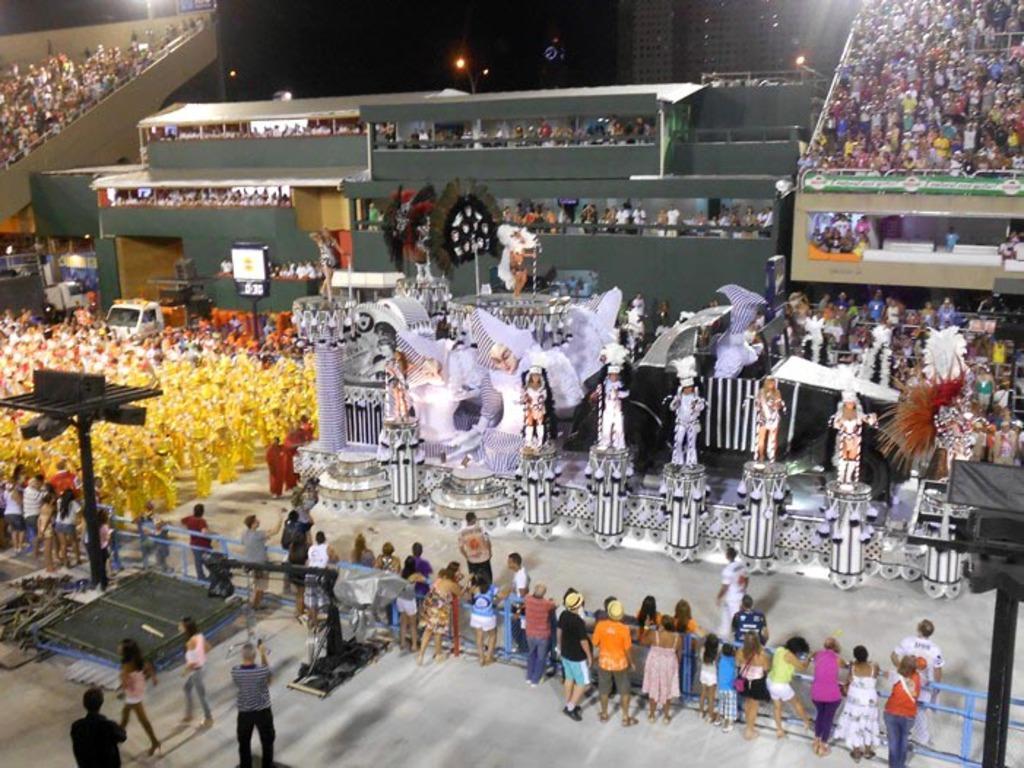Could you give a brief overview of what you see in this image? In this image there are a group of people some of them are wearing same costume and dancing, in the center and some of them are watching. In the background and also there are some lights, poles, vehicles, boards and some other objects. At the bottom there is a floor. 